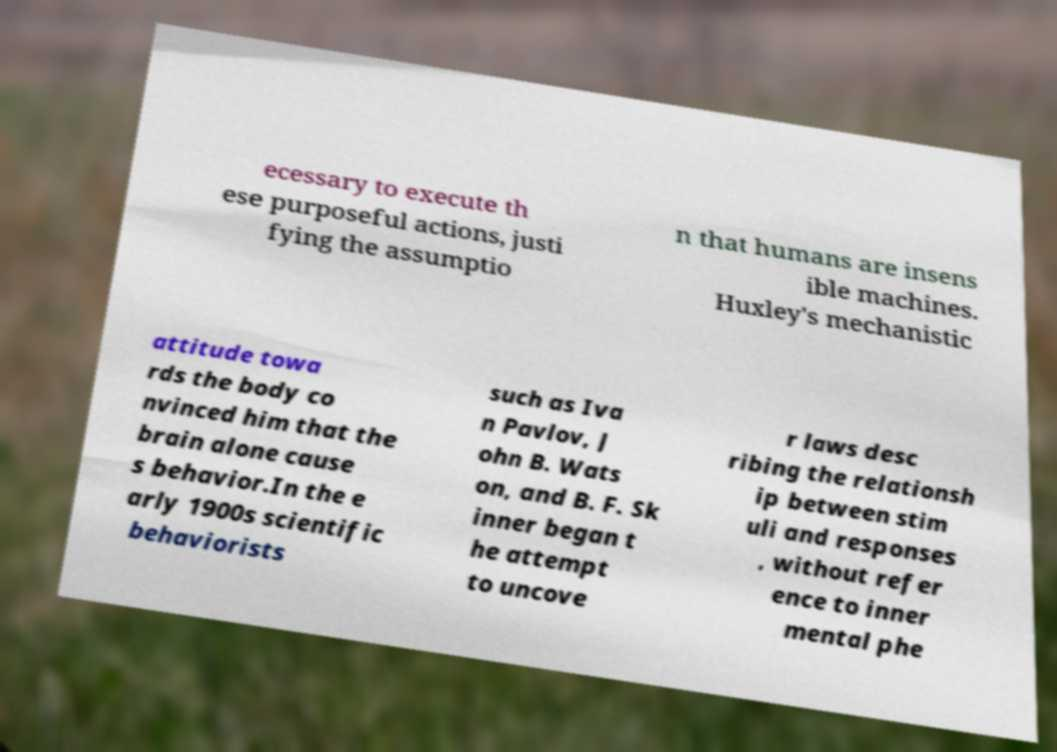Can you accurately transcribe the text from the provided image for me? ecessary to execute th ese purposeful actions, justi fying the assumptio n that humans are insens ible machines. Huxley's mechanistic attitude towa rds the body co nvinced him that the brain alone cause s behavior.In the e arly 1900s scientific behaviorists such as Iva n Pavlov, J ohn B. Wats on, and B. F. Sk inner began t he attempt to uncove r laws desc ribing the relationsh ip between stim uli and responses , without refer ence to inner mental phe 